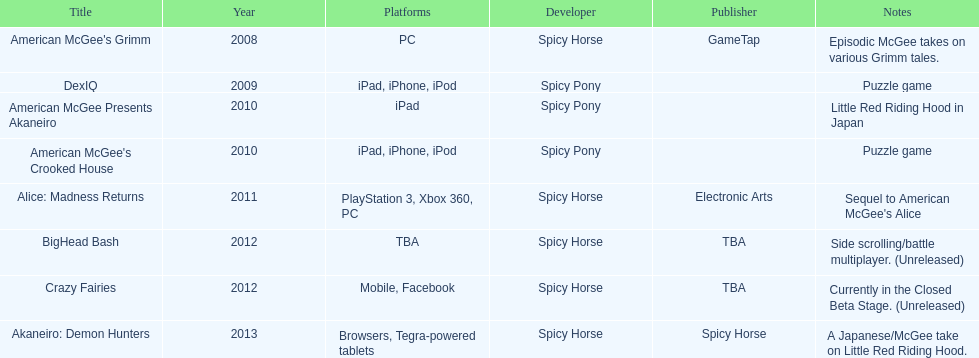Referring to the table, what was spicy horse's last developed title? Akaneiro: Demon Hunters. 